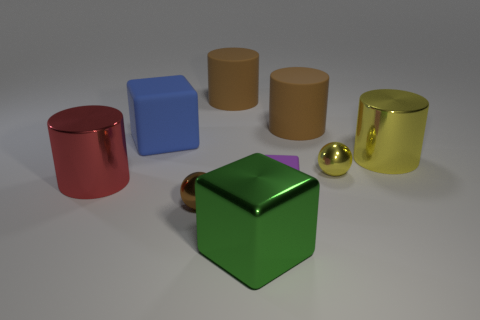Add 1 green metallic things. How many objects exist? 10 Subtract all large red cylinders. How many cylinders are left? 3 Subtract all cyan cubes. How many brown cylinders are left? 2 Subtract 2 cylinders. How many cylinders are left? 2 Subtract all brown balls. How many balls are left? 1 Subtract all spheres. How many objects are left? 7 Subtract all gray blocks. Subtract all cyan cylinders. How many blocks are left? 3 Subtract all tiny yellow things. Subtract all large yellow things. How many objects are left? 7 Add 9 yellow spheres. How many yellow spheres are left? 10 Add 1 big red objects. How many big red objects exist? 2 